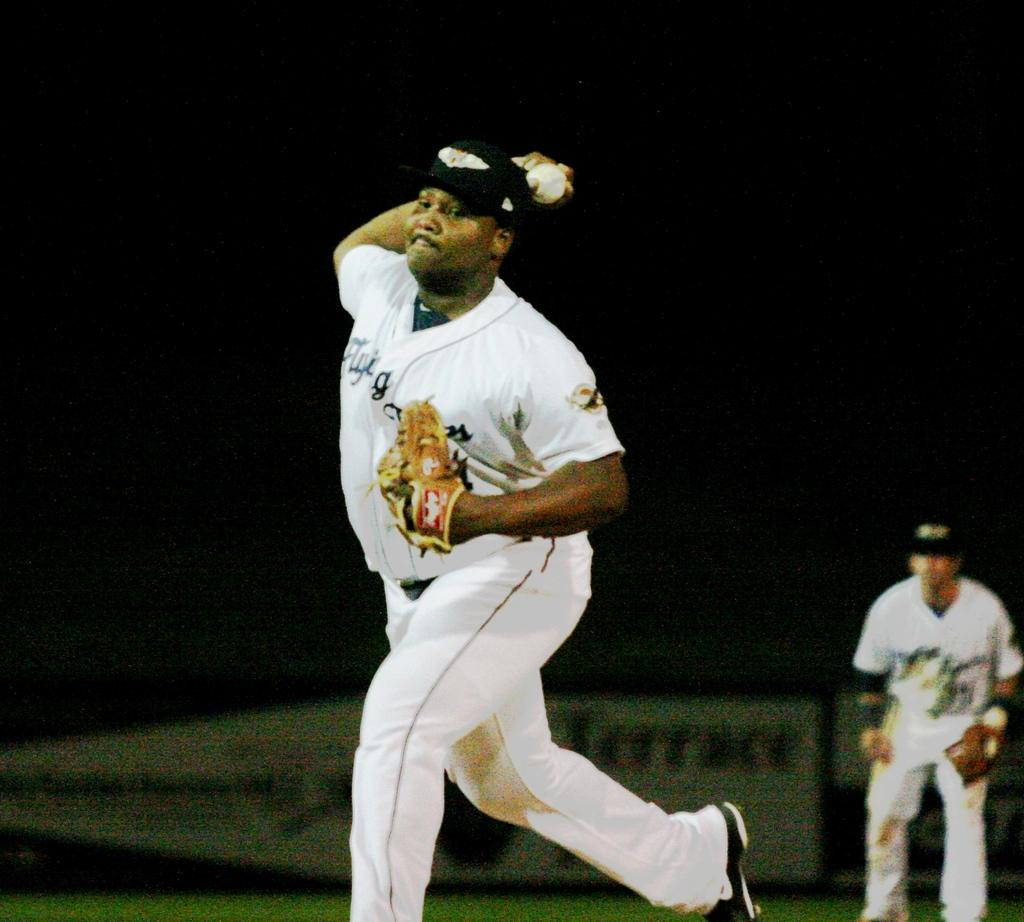What is the person in the image wearing on their head and hands? The person is wearing a cap and gloves in the image. What is the person holding in the image? The person is holding a ball in the image. Can you describe the background of the image? The background of the image is dark. Are there any other people visible in the image? Yes, there is another person in the background of the image. How does the person in the image handle the sleet while playing with the ball? There is no mention of sleet in the image, so it cannot be determined how the person would handle it. 